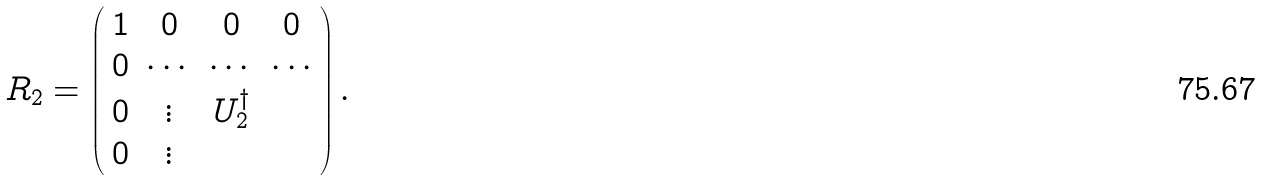Convert formula to latex. <formula><loc_0><loc_0><loc_500><loc_500>R _ { 2 } = \left ( \begin{array} { c c c c } 1 & 0 & 0 & 0 \\ 0 & \cdots & \cdots & \cdots \\ 0 & \vdots & U ^ { \dagger } _ { 2 } & \\ 0 & \vdots & & \end{array} \right ) .</formula> 